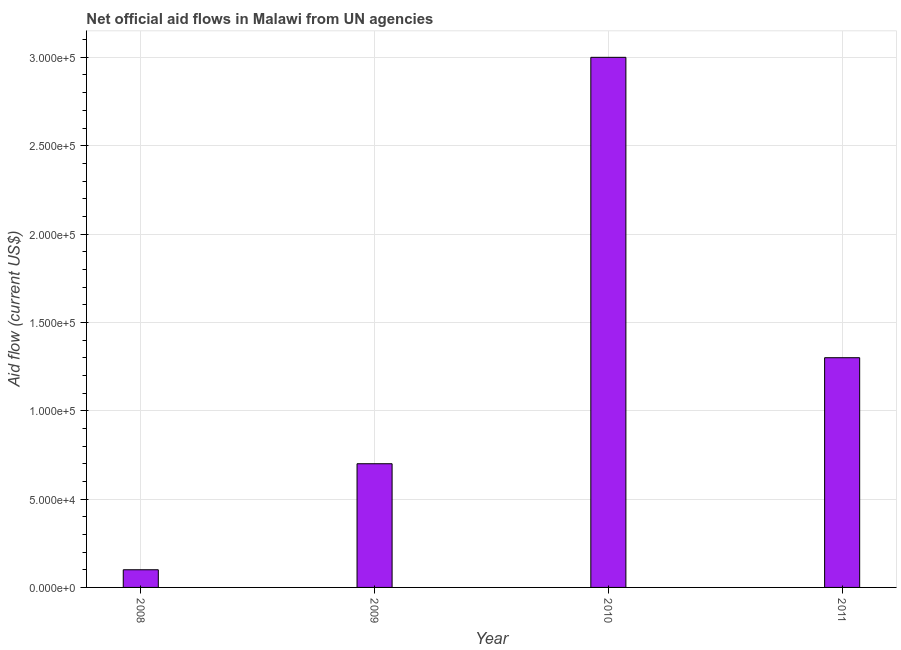Does the graph contain grids?
Make the answer very short. Yes. What is the title of the graph?
Give a very brief answer. Net official aid flows in Malawi from UN agencies. What is the label or title of the X-axis?
Provide a short and direct response. Year. What is the label or title of the Y-axis?
Your response must be concise. Aid flow (current US$). What is the net official flows from un agencies in 2008?
Your answer should be compact. 10000. Across all years, what is the maximum net official flows from un agencies?
Keep it short and to the point. 3.00e+05. Across all years, what is the minimum net official flows from un agencies?
Offer a very short reply. 10000. In which year was the net official flows from un agencies maximum?
Provide a succinct answer. 2010. What is the sum of the net official flows from un agencies?
Offer a very short reply. 5.10e+05. What is the average net official flows from un agencies per year?
Ensure brevity in your answer.  1.28e+05. What is the ratio of the net official flows from un agencies in 2010 to that in 2011?
Give a very brief answer. 2.31. Is the net official flows from un agencies in 2009 less than that in 2011?
Ensure brevity in your answer.  Yes. What is the difference between the highest and the lowest net official flows from un agencies?
Your answer should be very brief. 2.90e+05. In how many years, is the net official flows from un agencies greater than the average net official flows from un agencies taken over all years?
Your answer should be very brief. 2. How many years are there in the graph?
Provide a short and direct response. 4. Are the values on the major ticks of Y-axis written in scientific E-notation?
Your answer should be compact. Yes. What is the Aid flow (current US$) of 2010?
Keep it short and to the point. 3.00e+05. What is the Aid flow (current US$) in 2011?
Your response must be concise. 1.30e+05. What is the difference between the Aid flow (current US$) in 2008 and 2009?
Provide a succinct answer. -6.00e+04. What is the difference between the Aid flow (current US$) in 2009 and 2011?
Keep it short and to the point. -6.00e+04. What is the ratio of the Aid flow (current US$) in 2008 to that in 2009?
Make the answer very short. 0.14. What is the ratio of the Aid flow (current US$) in 2008 to that in 2010?
Offer a very short reply. 0.03. What is the ratio of the Aid flow (current US$) in 2008 to that in 2011?
Provide a short and direct response. 0.08. What is the ratio of the Aid flow (current US$) in 2009 to that in 2010?
Make the answer very short. 0.23. What is the ratio of the Aid flow (current US$) in 2009 to that in 2011?
Your answer should be very brief. 0.54. What is the ratio of the Aid flow (current US$) in 2010 to that in 2011?
Provide a succinct answer. 2.31. 